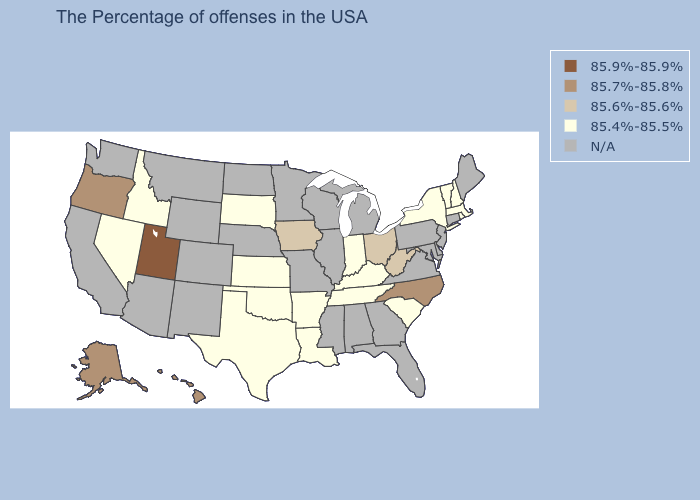Which states have the lowest value in the Northeast?
Quick response, please. Massachusetts, Rhode Island, New Hampshire, Vermont, New York. Which states have the lowest value in the USA?
Concise answer only. Massachusetts, Rhode Island, New Hampshire, Vermont, New York, South Carolina, Kentucky, Indiana, Tennessee, Louisiana, Arkansas, Kansas, Oklahoma, Texas, South Dakota, Idaho, Nevada. What is the value of Arkansas?
Give a very brief answer. 85.4%-85.5%. What is the value of Florida?
Short answer required. N/A. Does the map have missing data?
Quick response, please. Yes. What is the lowest value in the USA?
Give a very brief answer. 85.4%-85.5%. What is the highest value in the West ?
Quick response, please. 85.9%-85.9%. Among the states that border Washington , which have the highest value?
Keep it brief. Oregon. Among the states that border New York , which have the highest value?
Keep it brief. Massachusetts, Vermont. What is the value of Rhode Island?
Be succinct. 85.4%-85.5%. Name the states that have a value in the range 85.7%-85.8%?
Keep it brief. North Carolina, Oregon, Alaska, Hawaii. Name the states that have a value in the range 85.4%-85.5%?
Be succinct. Massachusetts, Rhode Island, New Hampshire, Vermont, New York, South Carolina, Kentucky, Indiana, Tennessee, Louisiana, Arkansas, Kansas, Oklahoma, Texas, South Dakota, Idaho, Nevada. 